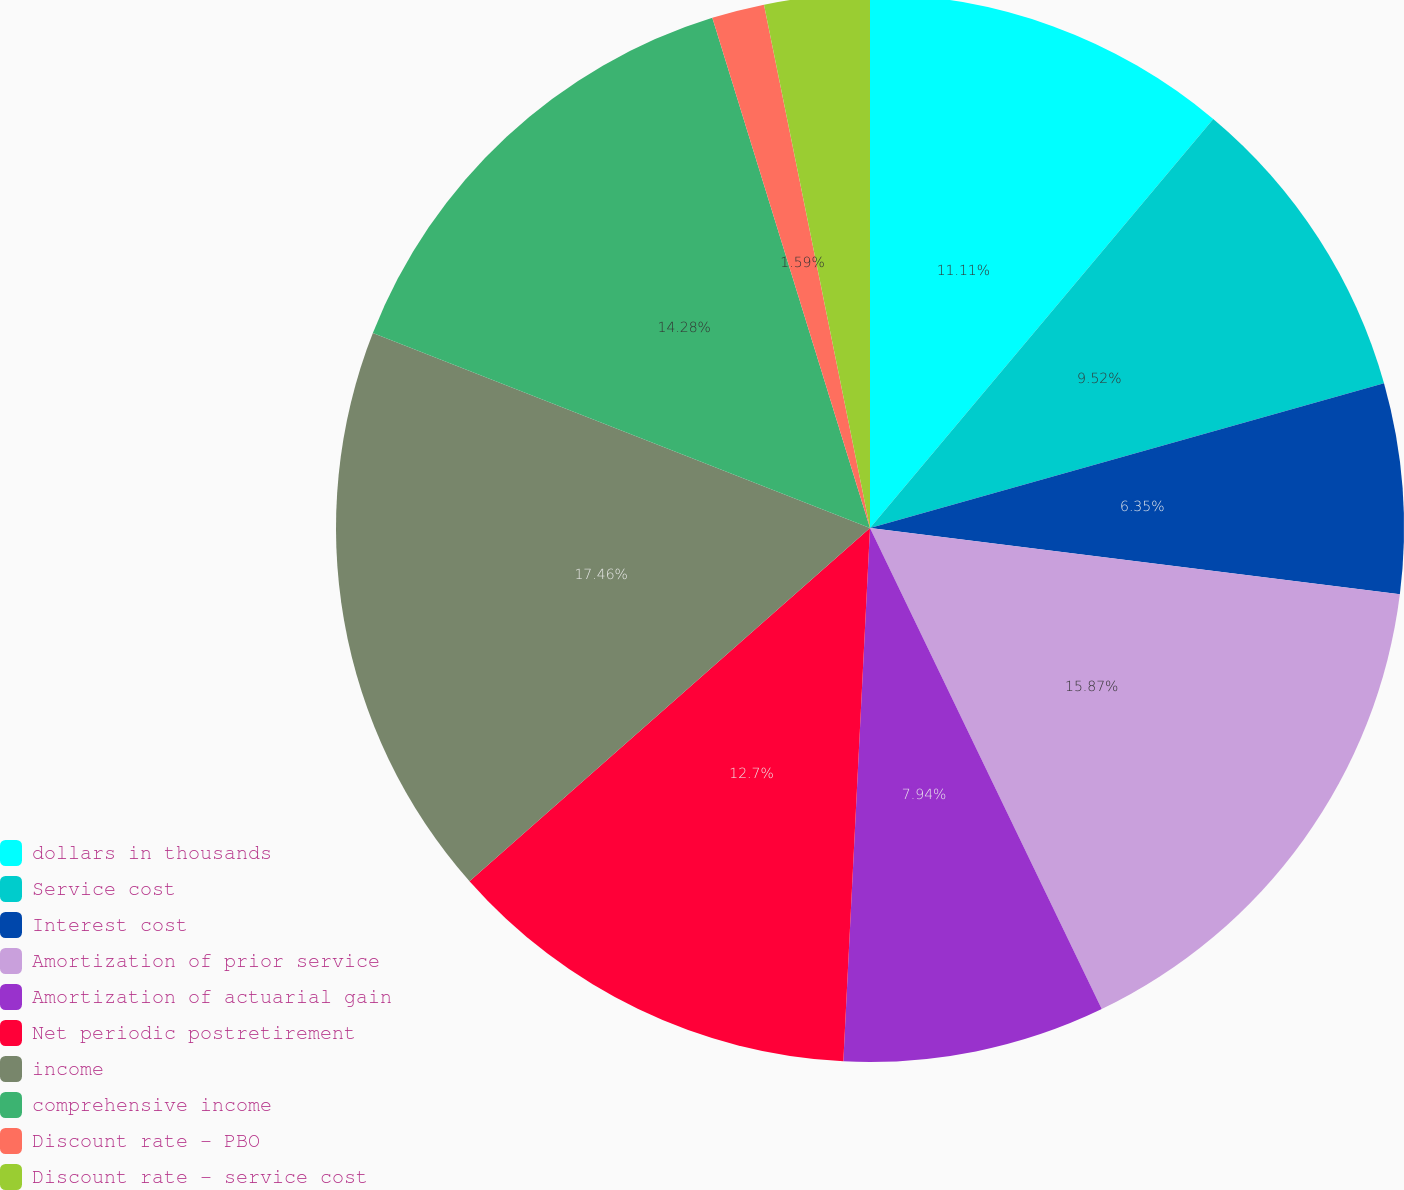Convert chart. <chart><loc_0><loc_0><loc_500><loc_500><pie_chart><fcel>dollars in thousands<fcel>Service cost<fcel>Interest cost<fcel>Amortization of prior service<fcel>Amortization of actuarial gain<fcel>Net periodic postretirement<fcel>income<fcel>comprehensive income<fcel>Discount rate - PBO<fcel>Discount rate - service cost<nl><fcel>11.11%<fcel>9.52%<fcel>6.35%<fcel>15.87%<fcel>7.94%<fcel>12.7%<fcel>17.45%<fcel>14.28%<fcel>1.59%<fcel>3.18%<nl></chart> 